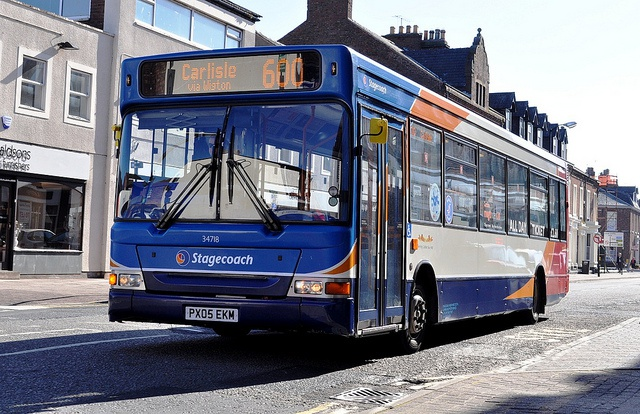Describe the objects in this image and their specific colors. I can see bus in darkgray, black, navy, and lightgray tones, people in darkgray, gray, navy, purple, and darkblue tones, and people in darkgray, black, and gray tones in this image. 